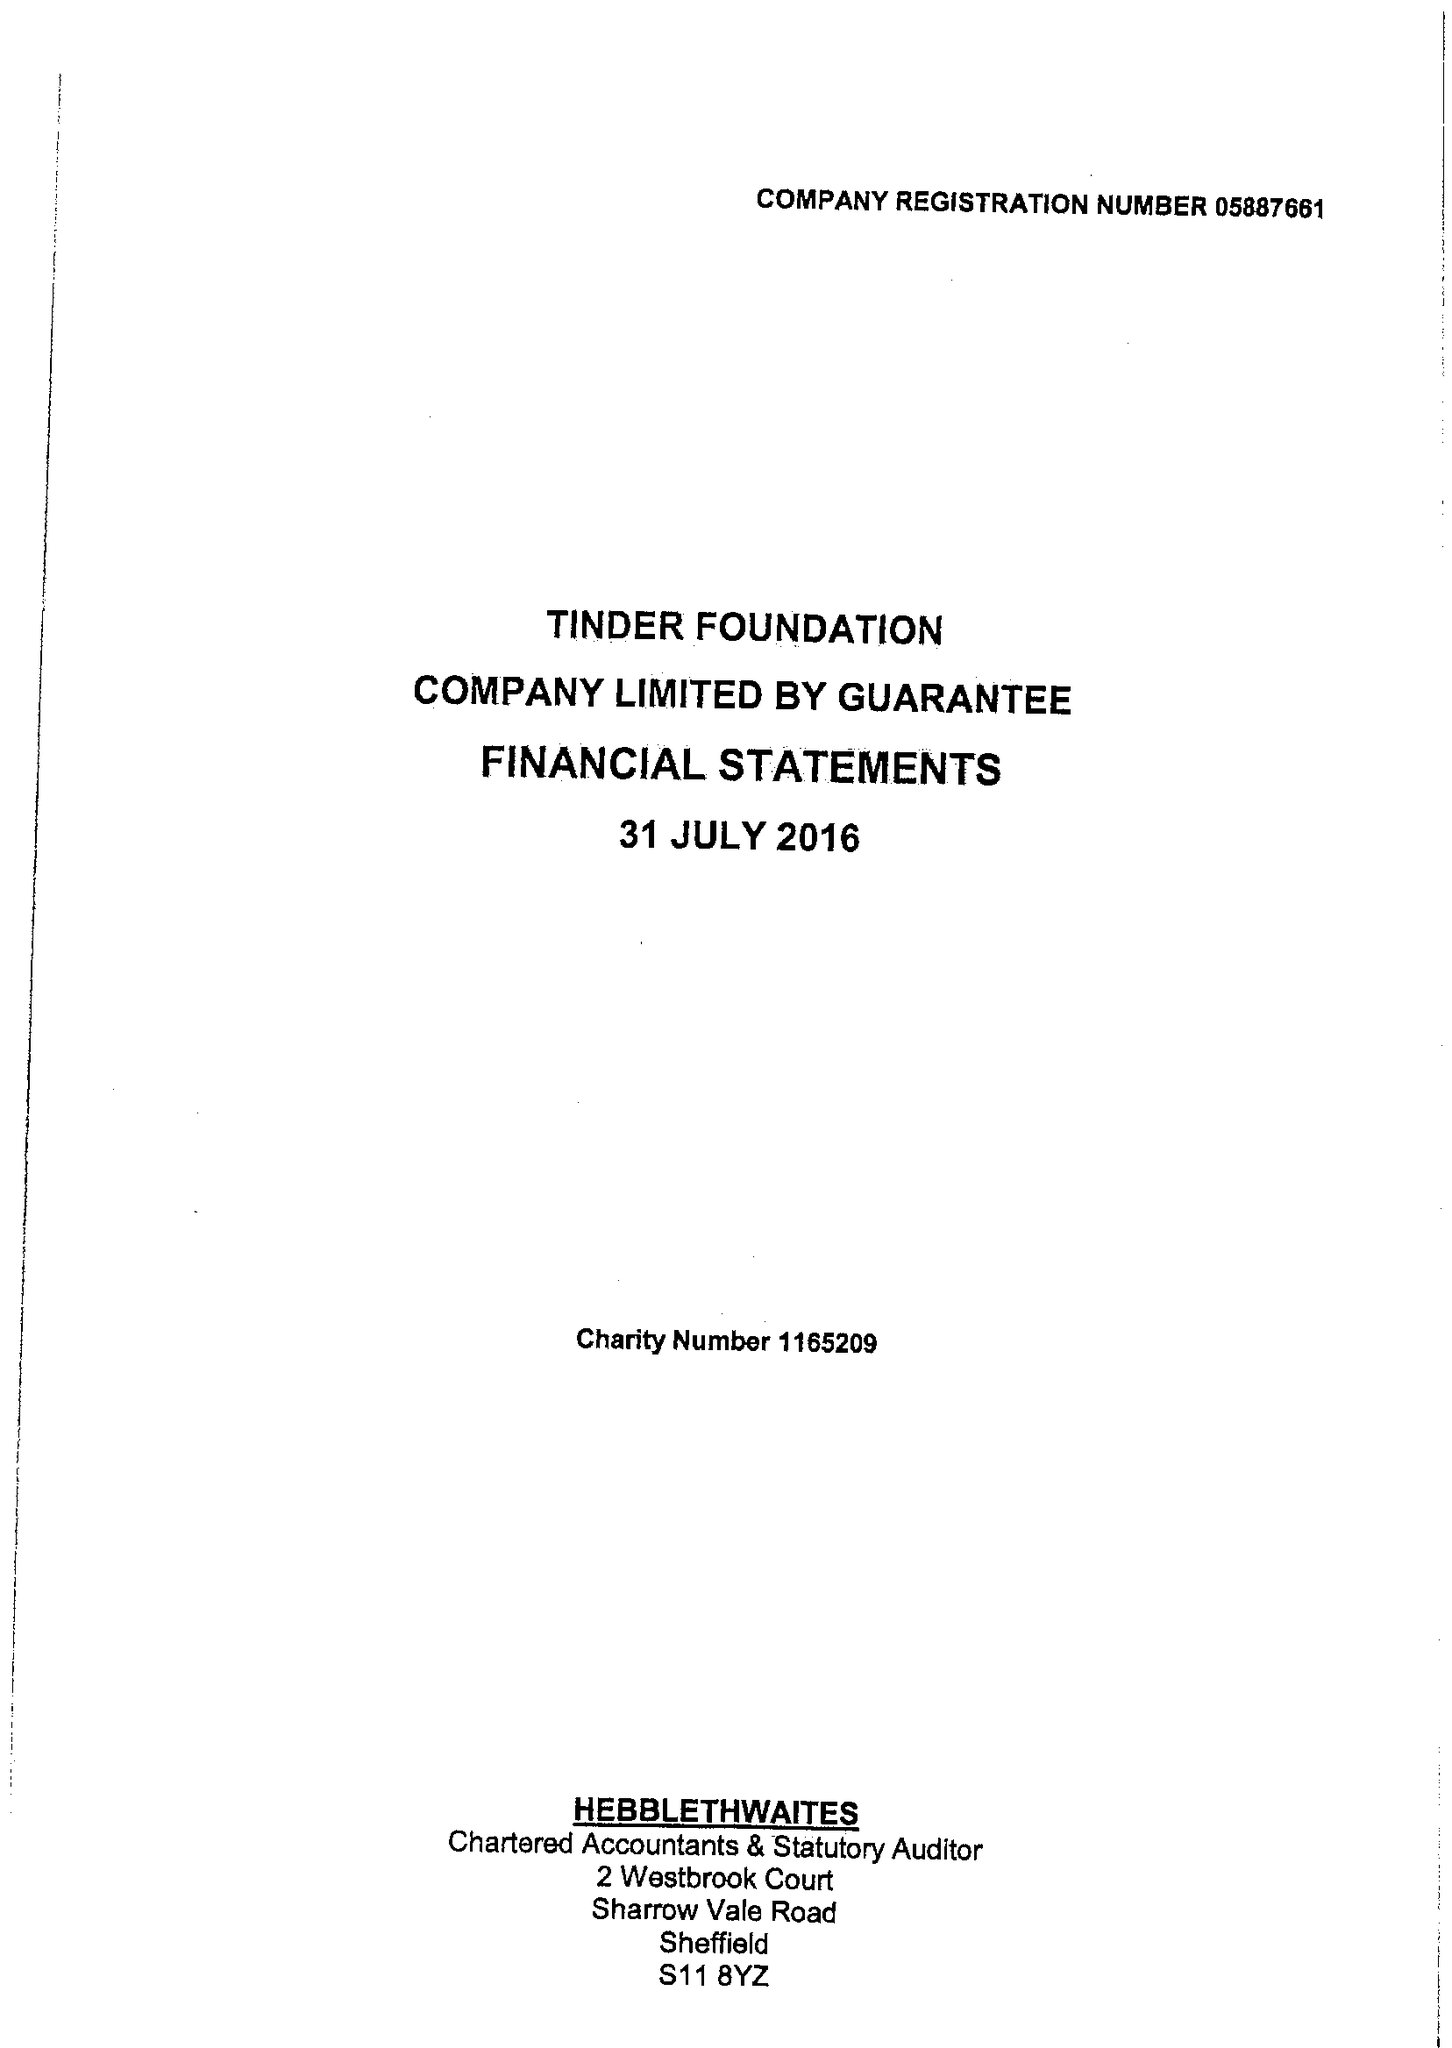What is the value for the spending_annually_in_british_pounds?
Answer the question using a single word or phrase. 6513569.00 